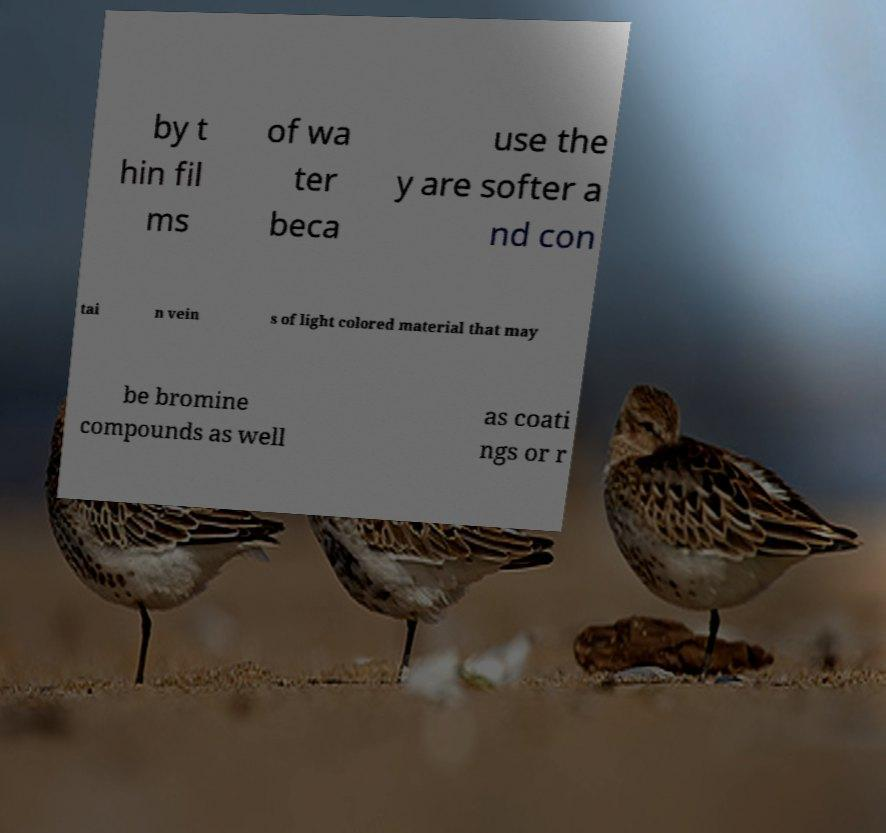I need the written content from this picture converted into text. Can you do that? by t hin fil ms of wa ter beca use the y are softer a nd con tai n vein s of light colored material that may be bromine compounds as well as coati ngs or r 